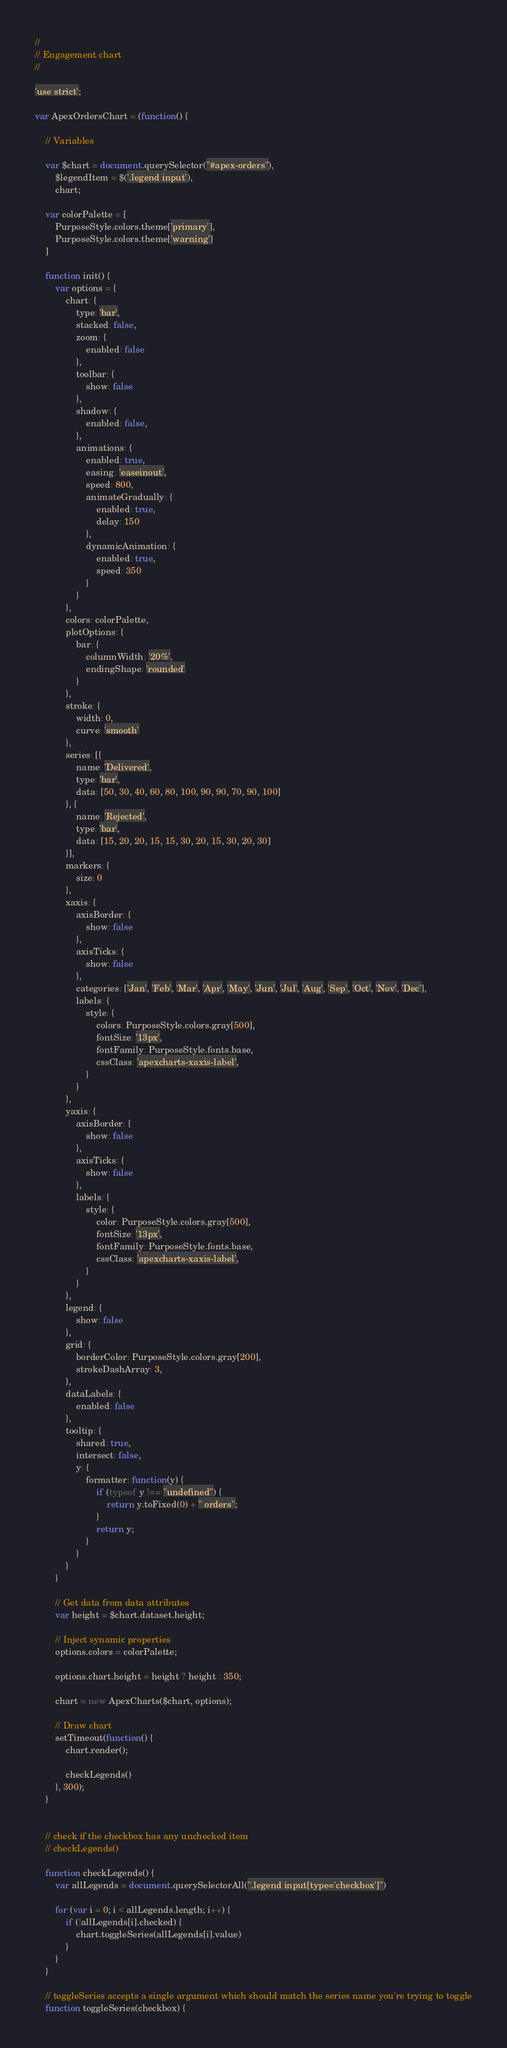Convert code to text. <code><loc_0><loc_0><loc_500><loc_500><_JavaScript_>//
// Engagement chart
//

'use strict';

var ApexOrdersChart = (function() {

	// Variables

	var $chart = document.querySelector("#apex-orders"),
		$legendItem = $('.legend input'),
		chart;

	var colorPalette = [
		PurposeStyle.colors.theme['primary'],
		PurposeStyle.colors.theme['warning']
	]

	function init() {
		var options = {
			chart: {
				type: 'bar',
				stacked: false,
				zoom: {
					enabled: false
				},
				toolbar: {
					show: false
				},
				shadow: {
					enabled: false,
				},
				animations: {
			        enabled: true,
			        easing: 'easeinout',
			        speed: 800,
			        animateGradually: {
			            enabled: true,
			            delay: 150
			        },
			        dynamicAnimation: {
			            enabled: true,
			            speed: 350
			        }
			    }
			},
			colors: colorPalette,
			plotOptions: {
				bar: {
					columnWidth: '20%',
					endingShape: 'rounded'
				}
			},
			stroke: {
				width: 0,
				curve: 'smooth'
			},
			series: [{
				name: 'Delivered',
				type: 'bar',
				data: [50, 30, 40, 60, 80, 100, 90, 90, 70, 90, 100]
			}, {
				name: 'Rejected',
				type: 'bar',
				data: [15, 20, 20, 15, 15, 30, 20, 15, 30, 20, 30]
			}],
			markers: {
				size: 0
			},
			xaxis: {
				axisBorder: {
					show: false
				},
				axisTicks: {
					show: false
				},
				categories: ['Jan', 'Feb', 'Mar', 'Apr', 'May', 'Jun', 'Jul', 'Aug', 'Sep', 'Oct', 'Nov', 'Dec'],
				labels: {
					style: {
						colors: PurposeStyle.colors.gray[500],
						fontSize: '13px',
						fontFamily: PurposeStyle.fonts.base,
						cssClass: 'apexcharts-xaxis-label',
					}
				}
			},
			yaxis: {
				axisBorder: {
					show: false
				},
				axisTicks: {
					show: false
				},
				labels: {
					style: {
						color: PurposeStyle.colors.gray[500],
						fontSize: '13px',
						fontFamily: PurposeStyle.fonts.base,
						cssClass: 'apexcharts-xaxis-label',
					}
				}
			},
			legend: {
				show: false
			},
			grid: {
				borderColor: PurposeStyle.colors.gray[200],
				strokeDashArray: 3,
			},
			dataLabels: {
				enabled: false
			},
			tooltip: {
				shared: true,
				intersect: false,
				y: {
					formatter: function(y) {
						if (typeof y !== "undefined") {
							return y.toFixed(0) + " orders";
						}
						return y;
					}
				}
			}
		}

		// Get data from data attributes
		var height = $chart.dataset.height;

		// Inject synamic properties
		options.colors = colorPalette;

		options.chart.height = height ? height : 350;

		chart = new ApexCharts($chart, options);

		// Draw chart
		setTimeout(function() {
			chart.render();

			checkLegends()
		}, 300);
	}


	// check if the checkbox has any unchecked item
	// checkLegends()

	function checkLegends() {
		var allLegends = document.querySelectorAll(".legend input[type='checkbox']")

		for (var i = 0; i < allLegends.length; i++) {
			if (!allLegends[i].checked) {
				chart.toggleSeries(allLegends[i].value)
			}
		}
	}

	// toggleSeries accepts a single argument which should match the series name you're trying to toggle
	function toggleSeries(checkbox) {</code> 